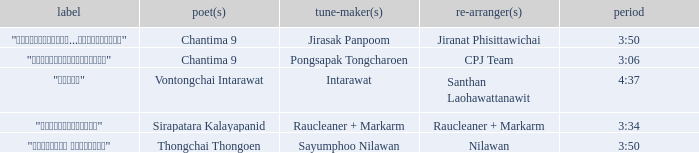Who was the composer of "ขอโทษ"? Intarawat. 